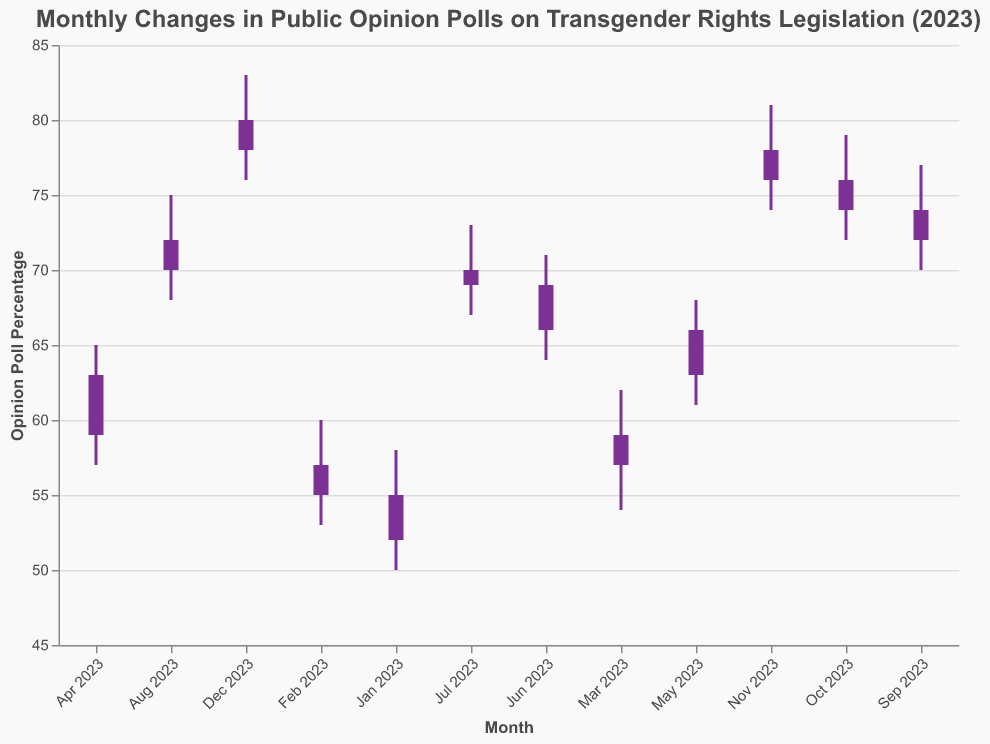What's the title of the figure? The title of the figure is displayed at the top. The title text is "Monthly Changes in Public Opinion Polls on Transgender Rights Legislation (2023)."
Answer: Monthly Changes in Public Opinion Polls on Transgender Rights Legislation (2023) What does the y-axis represent? The y-axis represents the "Opinion Poll Percentage." This information can be inferred from the axis title labeled on the left side of the figure.
Answer: Opinion Poll Percentage Which month has the highest 'High' value? The 'High' value for each month is plotted as the peak of the vertical line in each bar. December 2023 has the highest 'High' value of 83.
Answer: December 2023 How did the 'Close' value change from January 2023 to December 2023? The 'Close' value for January 2023 is 55, and for December 2023, it is 80. This shows an increase over the year.
Answer: Increased What is the difference between the 'Open' and 'Close' values for June 2023? For June 2023, the 'Open' value is 66, and the 'Close' value is 69. The difference is calculated as 69 - 66.
Answer: 3 In which months did the 'Close' value increase compared to the 'Open' value? By comparing the 'Open' and 'Close' values, we can see that the 'Close' value is higher than the 'Open' value for all months except July 2023, where the values are equal (69).
Answer: All months What is the average 'Low' value across all months? Sum all the 'Low' values (50 + 53 + 54 + 57 + 61 + 64 + 67 + 68 + 70 + 72 + 74 + 76) and divide by the number of months (12). The calculation is: (50 + 53 + 54 + 57 + 61 + 64 + 67 + 68 + 70 + 72 + 74 + 76) / 12 = 66.
Answer: 66 By how much did the 'High' value change from February 2023 to March 2023? The 'High' value for February 2023 is 60, and for March 2023, it is 62. Hence, the change is 62 - 60.
Answer: 2 In which month was the range between 'Low' and 'High' the largest? The range is the difference between 'High' and 'Low' values for each month. For April 2023, the range is 65 - 57 = 8, which is the largest.
Answer: April 2023 Which months have the 'Close' value lower than 70? The months with 'Close' values less than 70 are January 2023 (55), February 2023 (57), March 2023 (59), April 2023 (63), May 2023 (66), and June 2023 (69).
Answer: January to June 